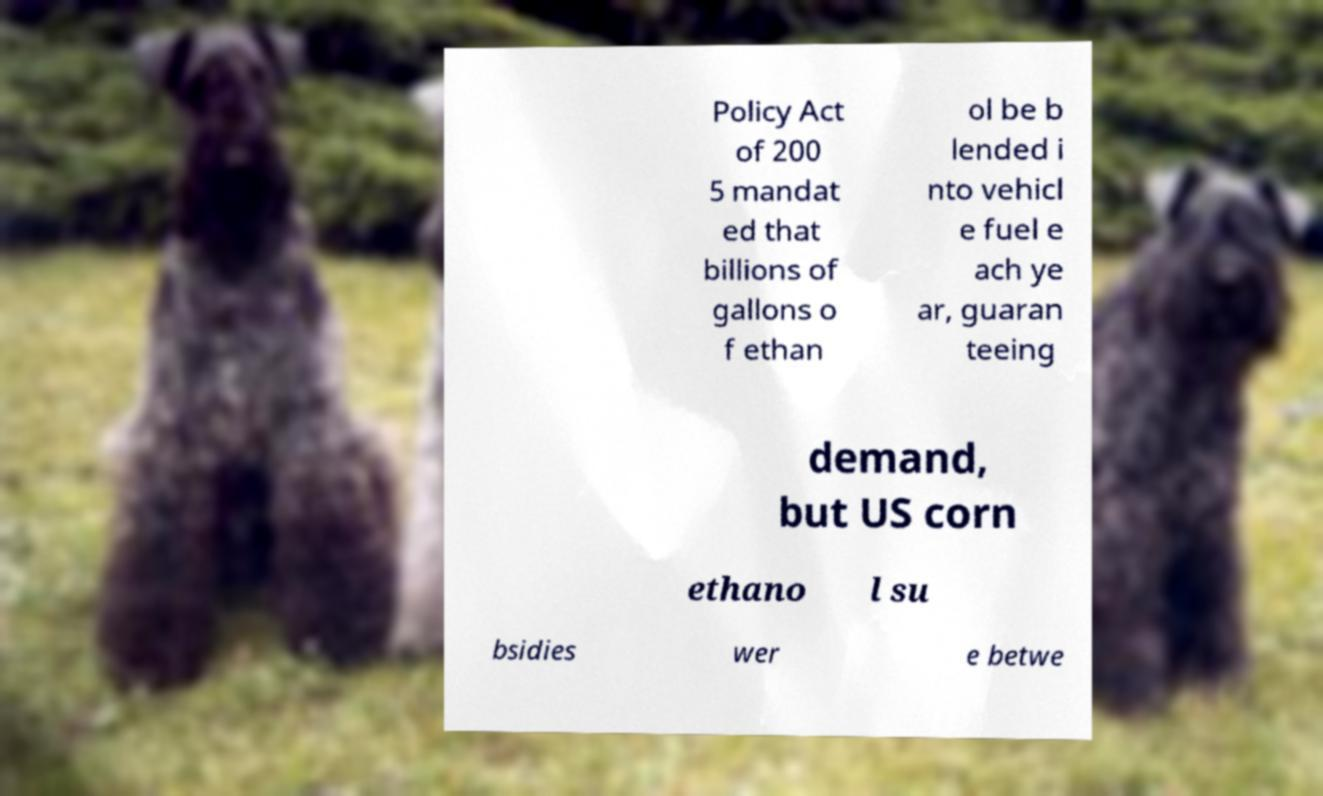I need the written content from this picture converted into text. Can you do that? Policy Act of 200 5 mandat ed that billions of gallons o f ethan ol be b lended i nto vehicl e fuel e ach ye ar, guaran teeing demand, but US corn ethano l su bsidies wer e betwe 